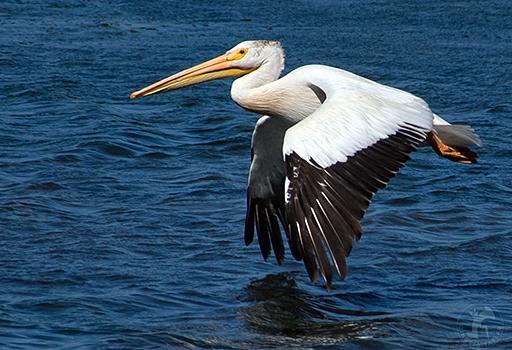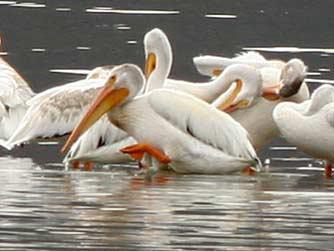The first image is the image on the left, the second image is the image on the right. Evaluate the accuracy of this statement regarding the images: "there is a single pelican in flight". Is it true? Answer yes or no. Yes. The first image is the image on the left, the second image is the image on the right. For the images shown, is this caption "The right image contains at least four birds." true? Answer yes or no. Yes. 